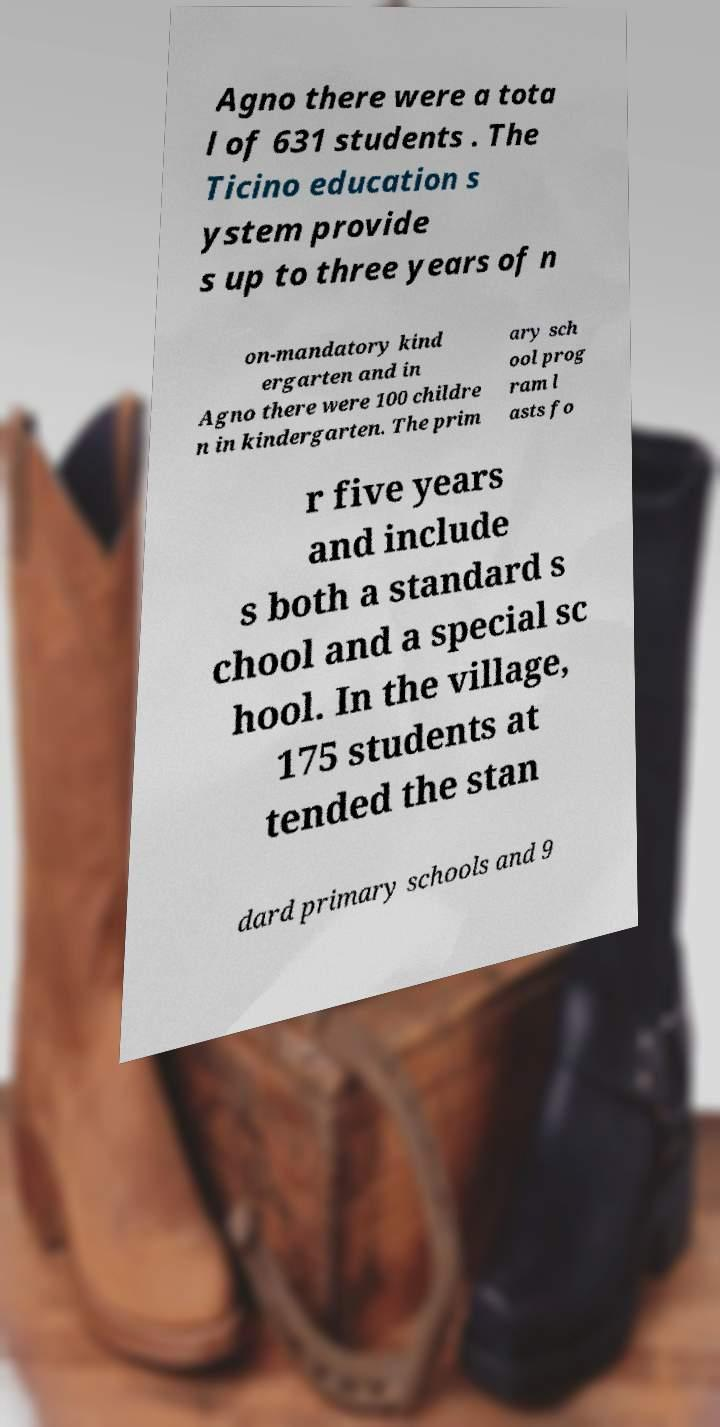Could you extract and type out the text from this image? Agno there were a tota l of 631 students . The Ticino education s ystem provide s up to three years of n on-mandatory kind ergarten and in Agno there were 100 childre n in kindergarten. The prim ary sch ool prog ram l asts fo r five years and include s both a standard s chool and a special sc hool. In the village, 175 students at tended the stan dard primary schools and 9 